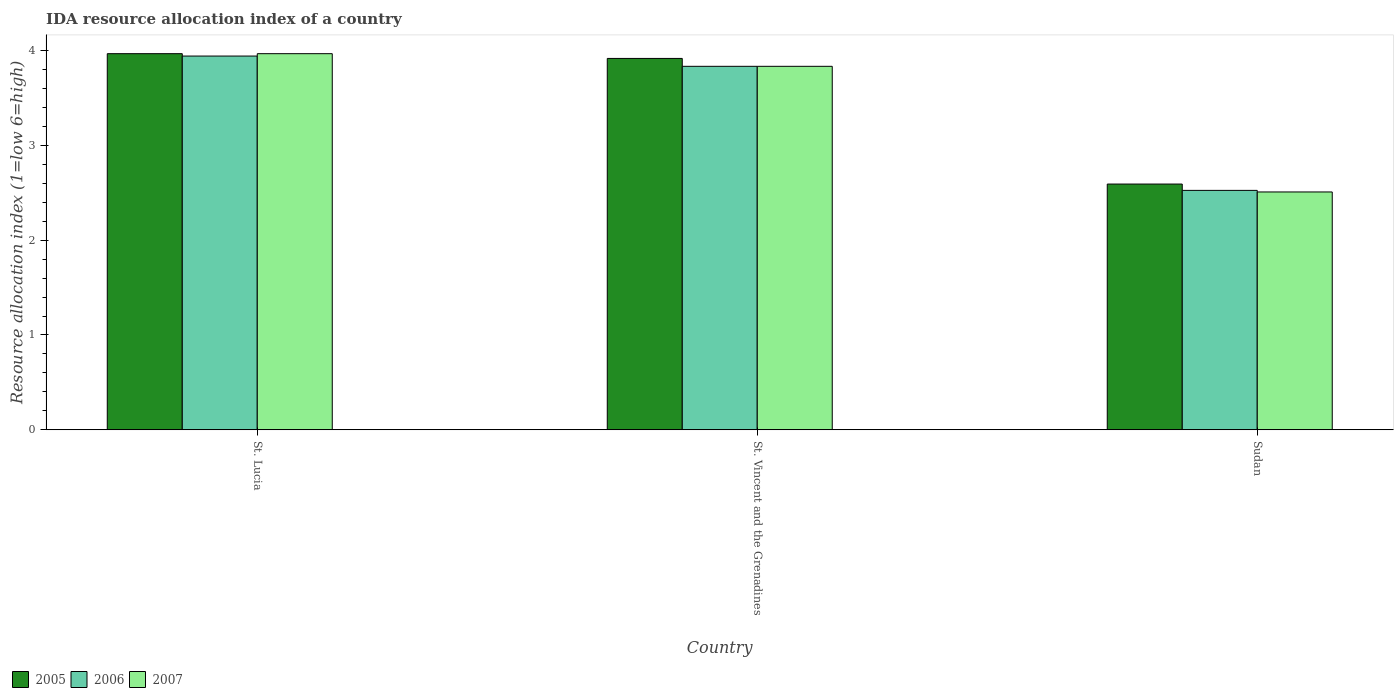How many different coloured bars are there?
Ensure brevity in your answer.  3. How many groups of bars are there?
Keep it short and to the point. 3. Are the number of bars per tick equal to the number of legend labels?
Ensure brevity in your answer.  Yes. What is the label of the 1st group of bars from the left?
Make the answer very short. St. Lucia. What is the IDA resource allocation index in 2005 in St. Vincent and the Grenadines?
Give a very brief answer. 3.92. Across all countries, what is the maximum IDA resource allocation index in 2007?
Provide a succinct answer. 3.97. Across all countries, what is the minimum IDA resource allocation index in 2007?
Your response must be concise. 2.51. In which country was the IDA resource allocation index in 2005 maximum?
Make the answer very short. St. Lucia. In which country was the IDA resource allocation index in 2005 minimum?
Your answer should be very brief. Sudan. What is the total IDA resource allocation index in 2006 in the graph?
Make the answer very short. 10.3. What is the difference between the IDA resource allocation index in 2006 in St. Lucia and that in St. Vincent and the Grenadines?
Ensure brevity in your answer.  0.11. What is the difference between the IDA resource allocation index in 2007 in Sudan and the IDA resource allocation index in 2006 in St. Lucia?
Your response must be concise. -1.43. What is the average IDA resource allocation index in 2006 per country?
Your answer should be very brief. 3.43. What is the difference between the IDA resource allocation index of/in 2006 and IDA resource allocation index of/in 2007 in St. Lucia?
Offer a terse response. -0.02. In how many countries, is the IDA resource allocation index in 2007 greater than 2?
Offer a terse response. 3. What is the ratio of the IDA resource allocation index in 2006 in St. Vincent and the Grenadines to that in Sudan?
Give a very brief answer. 1.52. Is the IDA resource allocation index in 2007 in St. Lucia less than that in St. Vincent and the Grenadines?
Your answer should be very brief. No. What is the difference between the highest and the second highest IDA resource allocation index in 2007?
Provide a succinct answer. 1.32. What is the difference between the highest and the lowest IDA resource allocation index in 2007?
Keep it short and to the point. 1.46. In how many countries, is the IDA resource allocation index in 2005 greater than the average IDA resource allocation index in 2005 taken over all countries?
Keep it short and to the point. 2. What does the 1st bar from the left in St. Lucia represents?
Provide a succinct answer. 2005. Are the values on the major ticks of Y-axis written in scientific E-notation?
Keep it short and to the point. No. Where does the legend appear in the graph?
Offer a very short reply. Bottom left. How many legend labels are there?
Offer a terse response. 3. What is the title of the graph?
Your answer should be compact. IDA resource allocation index of a country. Does "1998" appear as one of the legend labels in the graph?
Ensure brevity in your answer.  No. What is the label or title of the Y-axis?
Your response must be concise. Resource allocation index (1=low 6=high). What is the Resource allocation index (1=low 6=high) of 2005 in St. Lucia?
Offer a very short reply. 3.97. What is the Resource allocation index (1=low 6=high) in 2006 in St. Lucia?
Provide a succinct answer. 3.94. What is the Resource allocation index (1=low 6=high) of 2007 in St. Lucia?
Give a very brief answer. 3.97. What is the Resource allocation index (1=low 6=high) in 2005 in St. Vincent and the Grenadines?
Provide a succinct answer. 3.92. What is the Resource allocation index (1=low 6=high) in 2006 in St. Vincent and the Grenadines?
Keep it short and to the point. 3.83. What is the Resource allocation index (1=low 6=high) of 2007 in St. Vincent and the Grenadines?
Offer a terse response. 3.83. What is the Resource allocation index (1=low 6=high) in 2005 in Sudan?
Offer a terse response. 2.59. What is the Resource allocation index (1=low 6=high) in 2006 in Sudan?
Your response must be concise. 2.52. What is the Resource allocation index (1=low 6=high) in 2007 in Sudan?
Your response must be concise. 2.51. Across all countries, what is the maximum Resource allocation index (1=low 6=high) in 2005?
Provide a succinct answer. 3.97. Across all countries, what is the maximum Resource allocation index (1=low 6=high) of 2006?
Keep it short and to the point. 3.94. Across all countries, what is the maximum Resource allocation index (1=low 6=high) in 2007?
Offer a terse response. 3.97. Across all countries, what is the minimum Resource allocation index (1=low 6=high) of 2005?
Provide a succinct answer. 2.59. Across all countries, what is the minimum Resource allocation index (1=low 6=high) of 2006?
Offer a very short reply. 2.52. Across all countries, what is the minimum Resource allocation index (1=low 6=high) of 2007?
Give a very brief answer. 2.51. What is the total Resource allocation index (1=low 6=high) of 2005 in the graph?
Your answer should be very brief. 10.47. What is the total Resource allocation index (1=low 6=high) of 2006 in the graph?
Your response must be concise. 10.3. What is the total Resource allocation index (1=low 6=high) of 2007 in the graph?
Offer a very short reply. 10.31. What is the difference between the Resource allocation index (1=low 6=high) in 2005 in St. Lucia and that in St. Vincent and the Grenadines?
Provide a succinct answer. 0.05. What is the difference between the Resource allocation index (1=low 6=high) in 2006 in St. Lucia and that in St. Vincent and the Grenadines?
Provide a succinct answer. 0.11. What is the difference between the Resource allocation index (1=low 6=high) in 2007 in St. Lucia and that in St. Vincent and the Grenadines?
Provide a succinct answer. 0.13. What is the difference between the Resource allocation index (1=low 6=high) in 2005 in St. Lucia and that in Sudan?
Your answer should be very brief. 1.38. What is the difference between the Resource allocation index (1=low 6=high) of 2006 in St. Lucia and that in Sudan?
Give a very brief answer. 1.42. What is the difference between the Resource allocation index (1=low 6=high) in 2007 in St. Lucia and that in Sudan?
Offer a very short reply. 1.46. What is the difference between the Resource allocation index (1=low 6=high) of 2005 in St. Vincent and the Grenadines and that in Sudan?
Your answer should be compact. 1.32. What is the difference between the Resource allocation index (1=low 6=high) in 2006 in St. Vincent and the Grenadines and that in Sudan?
Offer a very short reply. 1.31. What is the difference between the Resource allocation index (1=low 6=high) of 2007 in St. Vincent and the Grenadines and that in Sudan?
Your answer should be very brief. 1.32. What is the difference between the Resource allocation index (1=low 6=high) of 2005 in St. Lucia and the Resource allocation index (1=low 6=high) of 2006 in St. Vincent and the Grenadines?
Keep it short and to the point. 0.13. What is the difference between the Resource allocation index (1=low 6=high) of 2005 in St. Lucia and the Resource allocation index (1=low 6=high) of 2007 in St. Vincent and the Grenadines?
Keep it short and to the point. 0.13. What is the difference between the Resource allocation index (1=low 6=high) in 2006 in St. Lucia and the Resource allocation index (1=low 6=high) in 2007 in St. Vincent and the Grenadines?
Offer a very short reply. 0.11. What is the difference between the Resource allocation index (1=low 6=high) in 2005 in St. Lucia and the Resource allocation index (1=low 6=high) in 2006 in Sudan?
Make the answer very short. 1.44. What is the difference between the Resource allocation index (1=low 6=high) of 2005 in St. Lucia and the Resource allocation index (1=low 6=high) of 2007 in Sudan?
Offer a terse response. 1.46. What is the difference between the Resource allocation index (1=low 6=high) of 2006 in St. Lucia and the Resource allocation index (1=low 6=high) of 2007 in Sudan?
Offer a very short reply. 1.43. What is the difference between the Resource allocation index (1=low 6=high) of 2005 in St. Vincent and the Grenadines and the Resource allocation index (1=low 6=high) of 2006 in Sudan?
Offer a very short reply. 1.39. What is the difference between the Resource allocation index (1=low 6=high) of 2005 in St. Vincent and the Grenadines and the Resource allocation index (1=low 6=high) of 2007 in Sudan?
Your response must be concise. 1.41. What is the difference between the Resource allocation index (1=low 6=high) of 2006 in St. Vincent and the Grenadines and the Resource allocation index (1=low 6=high) of 2007 in Sudan?
Offer a very short reply. 1.32. What is the average Resource allocation index (1=low 6=high) of 2005 per country?
Ensure brevity in your answer.  3.49. What is the average Resource allocation index (1=low 6=high) of 2006 per country?
Your response must be concise. 3.43. What is the average Resource allocation index (1=low 6=high) in 2007 per country?
Offer a very short reply. 3.44. What is the difference between the Resource allocation index (1=low 6=high) in 2005 and Resource allocation index (1=low 6=high) in 2006 in St. Lucia?
Provide a succinct answer. 0.03. What is the difference between the Resource allocation index (1=low 6=high) of 2006 and Resource allocation index (1=low 6=high) of 2007 in St. Lucia?
Make the answer very short. -0.03. What is the difference between the Resource allocation index (1=low 6=high) of 2005 and Resource allocation index (1=low 6=high) of 2006 in St. Vincent and the Grenadines?
Provide a succinct answer. 0.08. What is the difference between the Resource allocation index (1=low 6=high) in 2005 and Resource allocation index (1=low 6=high) in 2007 in St. Vincent and the Grenadines?
Give a very brief answer. 0.08. What is the difference between the Resource allocation index (1=low 6=high) in 2006 and Resource allocation index (1=low 6=high) in 2007 in St. Vincent and the Grenadines?
Provide a succinct answer. 0. What is the difference between the Resource allocation index (1=low 6=high) of 2005 and Resource allocation index (1=low 6=high) of 2006 in Sudan?
Make the answer very short. 0.07. What is the difference between the Resource allocation index (1=low 6=high) in 2005 and Resource allocation index (1=low 6=high) in 2007 in Sudan?
Provide a short and direct response. 0.08. What is the difference between the Resource allocation index (1=low 6=high) in 2006 and Resource allocation index (1=low 6=high) in 2007 in Sudan?
Make the answer very short. 0.02. What is the ratio of the Resource allocation index (1=low 6=high) in 2005 in St. Lucia to that in St. Vincent and the Grenadines?
Your answer should be very brief. 1.01. What is the ratio of the Resource allocation index (1=low 6=high) in 2006 in St. Lucia to that in St. Vincent and the Grenadines?
Your answer should be very brief. 1.03. What is the ratio of the Resource allocation index (1=low 6=high) of 2007 in St. Lucia to that in St. Vincent and the Grenadines?
Make the answer very short. 1.03. What is the ratio of the Resource allocation index (1=low 6=high) in 2005 in St. Lucia to that in Sudan?
Ensure brevity in your answer.  1.53. What is the ratio of the Resource allocation index (1=low 6=high) of 2006 in St. Lucia to that in Sudan?
Offer a terse response. 1.56. What is the ratio of the Resource allocation index (1=low 6=high) in 2007 in St. Lucia to that in Sudan?
Offer a very short reply. 1.58. What is the ratio of the Resource allocation index (1=low 6=high) in 2005 in St. Vincent and the Grenadines to that in Sudan?
Your answer should be very brief. 1.51. What is the ratio of the Resource allocation index (1=low 6=high) in 2006 in St. Vincent and the Grenadines to that in Sudan?
Provide a succinct answer. 1.52. What is the ratio of the Resource allocation index (1=low 6=high) in 2007 in St. Vincent and the Grenadines to that in Sudan?
Your response must be concise. 1.53. What is the difference between the highest and the second highest Resource allocation index (1=low 6=high) of 2006?
Keep it short and to the point. 0.11. What is the difference between the highest and the second highest Resource allocation index (1=low 6=high) in 2007?
Provide a succinct answer. 0.13. What is the difference between the highest and the lowest Resource allocation index (1=low 6=high) of 2005?
Ensure brevity in your answer.  1.38. What is the difference between the highest and the lowest Resource allocation index (1=low 6=high) in 2006?
Provide a succinct answer. 1.42. What is the difference between the highest and the lowest Resource allocation index (1=low 6=high) in 2007?
Make the answer very short. 1.46. 